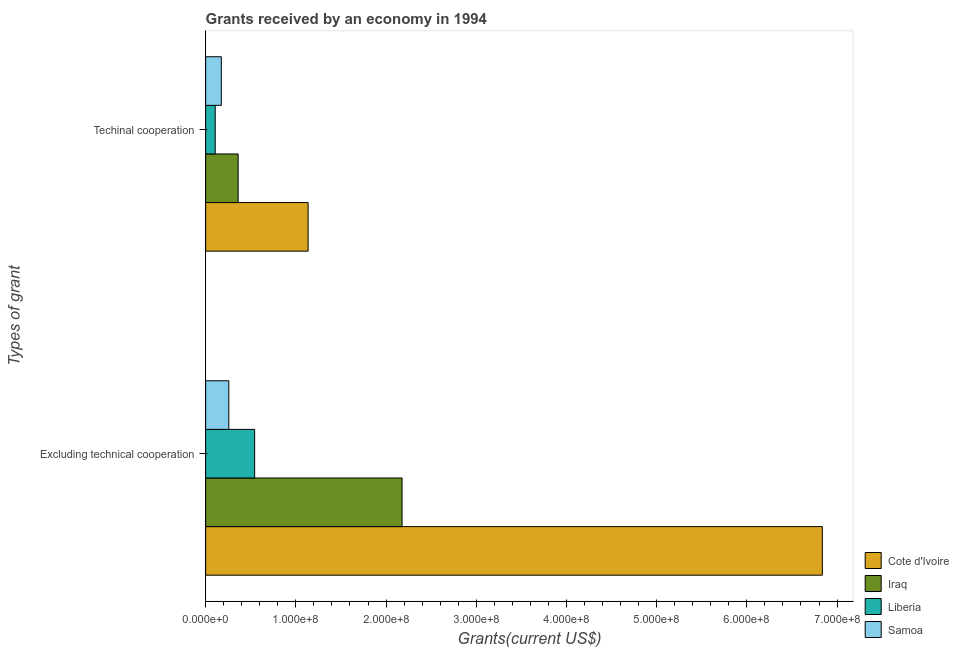How many different coloured bars are there?
Give a very brief answer. 4. Are the number of bars per tick equal to the number of legend labels?
Ensure brevity in your answer.  Yes. Are the number of bars on each tick of the Y-axis equal?
Provide a short and direct response. Yes. How many bars are there on the 1st tick from the top?
Ensure brevity in your answer.  4. What is the label of the 2nd group of bars from the top?
Ensure brevity in your answer.  Excluding technical cooperation. What is the amount of grants received(excluding technical cooperation) in Iraq?
Provide a short and direct response. 2.18e+08. Across all countries, what is the maximum amount of grants received(excluding technical cooperation)?
Make the answer very short. 6.84e+08. Across all countries, what is the minimum amount of grants received(including technical cooperation)?
Offer a very short reply. 1.06e+07. In which country was the amount of grants received(excluding technical cooperation) maximum?
Give a very brief answer. Cote d'Ivoire. In which country was the amount of grants received(excluding technical cooperation) minimum?
Your answer should be very brief. Samoa. What is the total amount of grants received(including technical cooperation) in the graph?
Make the answer very short. 1.78e+08. What is the difference between the amount of grants received(excluding technical cooperation) in Iraq and that in Cote d'Ivoire?
Provide a succinct answer. -4.66e+08. What is the difference between the amount of grants received(excluding technical cooperation) in Iraq and the amount of grants received(including technical cooperation) in Samoa?
Give a very brief answer. 2.00e+08. What is the average amount of grants received(excluding technical cooperation) per country?
Provide a short and direct response. 2.45e+08. What is the difference between the amount of grants received(including technical cooperation) and amount of grants received(excluding technical cooperation) in Iraq?
Your response must be concise. -1.82e+08. What is the ratio of the amount of grants received(excluding technical cooperation) in Cote d'Ivoire to that in Samoa?
Your answer should be very brief. 26.6. In how many countries, is the amount of grants received(including technical cooperation) greater than the average amount of grants received(including technical cooperation) taken over all countries?
Provide a succinct answer. 1. What does the 2nd bar from the top in Techinal cooperation represents?
Offer a very short reply. Liberia. What does the 4th bar from the bottom in Excluding technical cooperation represents?
Provide a succinct answer. Samoa. Are all the bars in the graph horizontal?
Ensure brevity in your answer.  Yes. How many countries are there in the graph?
Give a very brief answer. 4. Are the values on the major ticks of X-axis written in scientific E-notation?
Provide a short and direct response. Yes. Where does the legend appear in the graph?
Offer a terse response. Bottom right. How are the legend labels stacked?
Offer a terse response. Vertical. What is the title of the graph?
Give a very brief answer. Grants received by an economy in 1994. What is the label or title of the X-axis?
Your answer should be very brief. Grants(current US$). What is the label or title of the Y-axis?
Provide a short and direct response. Types of grant. What is the Grants(current US$) in Cote d'Ivoire in Excluding technical cooperation?
Provide a succinct answer. 6.84e+08. What is the Grants(current US$) in Iraq in Excluding technical cooperation?
Provide a succinct answer. 2.18e+08. What is the Grants(current US$) of Liberia in Excluding technical cooperation?
Offer a very short reply. 5.43e+07. What is the Grants(current US$) in Samoa in Excluding technical cooperation?
Offer a very short reply. 2.57e+07. What is the Grants(current US$) of Cote d'Ivoire in Techinal cooperation?
Offer a very short reply. 1.14e+08. What is the Grants(current US$) of Iraq in Techinal cooperation?
Your answer should be very brief. 3.61e+07. What is the Grants(current US$) in Liberia in Techinal cooperation?
Keep it short and to the point. 1.06e+07. What is the Grants(current US$) of Samoa in Techinal cooperation?
Keep it short and to the point. 1.74e+07. Across all Types of grant, what is the maximum Grants(current US$) in Cote d'Ivoire?
Your response must be concise. 6.84e+08. Across all Types of grant, what is the maximum Grants(current US$) of Iraq?
Your answer should be compact. 2.18e+08. Across all Types of grant, what is the maximum Grants(current US$) of Liberia?
Give a very brief answer. 5.43e+07. Across all Types of grant, what is the maximum Grants(current US$) of Samoa?
Keep it short and to the point. 2.57e+07. Across all Types of grant, what is the minimum Grants(current US$) of Cote d'Ivoire?
Your answer should be compact. 1.14e+08. Across all Types of grant, what is the minimum Grants(current US$) in Iraq?
Make the answer very short. 3.61e+07. Across all Types of grant, what is the minimum Grants(current US$) in Liberia?
Your response must be concise. 1.06e+07. Across all Types of grant, what is the minimum Grants(current US$) in Samoa?
Make the answer very short. 1.74e+07. What is the total Grants(current US$) of Cote d'Ivoire in the graph?
Your answer should be very brief. 7.97e+08. What is the total Grants(current US$) of Iraq in the graph?
Your answer should be very brief. 2.54e+08. What is the total Grants(current US$) of Liberia in the graph?
Offer a terse response. 6.50e+07. What is the total Grants(current US$) of Samoa in the graph?
Ensure brevity in your answer.  4.31e+07. What is the difference between the Grants(current US$) in Cote d'Ivoire in Excluding technical cooperation and that in Techinal cooperation?
Ensure brevity in your answer.  5.70e+08. What is the difference between the Grants(current US$) in Iraq in Excluding technical cooperation and that in Techinal cooperation?
Ensure brevity in your answer.  1.82e+08. What is the difference between the Grants(current US$) in Liberia in Excluding technical cooperation and that in Techinal cooperation?
Keep it short and to the point. 4.37e+07. What is the difference between the Grants(current US$) of Samoa in Excluding technical cooperation and that in Techinal cooperation?
Provide a short and direct response. 8.31e+06. What is the difference between the Grants(current US$) in Cote d'Ivoire in Excluding technical cooperation and the Grants(current US$) in Iraq in Techinal cooperation?
Your response must be concise. 6.48e+08. What is the difference between the Grants(current US$) in Cote d'Ivoire in Excluding technical cooperation and the Grants(current US$) in Liberia in Techinal cooperation?
Keep it short and to the point. 6.73e+08. What is the difference between the Grants(current US$) in Cote d'Ivoire in Excluding technical cooperation and the Grants(current US$) in Samoa in Techinal cooperation?
Your answer should be very brief. 6.66e+08. What is the difference between the Grants(current US$) in Iraq in Excluding technical cooperation and the Grants(current US$) in Liberia in Techinal cooperation?
Keep it short and to the point. 2.07e+08. What is the difference between the Grants(current US$) of Iraq in Excluding technical cooperation and the Grants(current US$) of Samoa in Techinal cooperation?
Provide a succinct answer. 2.00e+08. What is the difference between the Grants(current US$) of Liberia in Excluding technical cooperation and the Grants(current US$) of Samoa in Techinal cooperation?
Offer a very short reply. 3.70e+07. What is the average Grants(current US$) in Cote d'Ivoire per Types of grant?
Your answer should be compact. 3.99e+08. What is the average Grants(current US$) in Iraq per Types of grant?
Your answer should be compact. 1.27e+08. What is the average Grants(current US$) in Liberia per Types of grant?
Make the answer very short. 3.25e+07. What is the average Grants(current US$) of Samoa per Types of grant?
Your response must be concise. 2.15e+07. What is the difference between the Grants(current US$) in Cote d'Ivoire and Grants(current US$) in Iraq in Excluding technical cooperation?
Make the answer very short. 4.66e+08. What is the difference between the Grants(current US$) in Cote d'Ivoire and Grants(current US$) in Liberia in Excluding technical cooperation?
Your answer should be very brief. 6.29e+08. What is the difference between the Grants(current US$) of Cote d'Ivoire and Grants(current US$) of Samoa in Excluding technical cooperation?
Offer a very short reply. 6.58e+08. What is the difference between the Grants(current US$) in Iraq and Grants(current US$) in Liberia in Excluding technical cooperation?
Provide a succinct answer. 1.63e+08. What is the difference between the Grants(current US$) in Iraq and Grants(current US$) in Samoa in Excluding technical cooperation?
Your answer should be compact. 1.92e+08. What is the difference between the Grants(current US$) in Liberia and Grants(current US$) in Samoa in Excluding technical cooperation?
Ensure brevity in your answer.  2.86e+07. What is the difference between the Grants(current US$) of Cote d'Ivoire and Grants(current US$) of Iraq in Techinal cooperation?
Offer a terse response. 7.76e+07. What is the difference between the Grants(current US$) of Cote d'Ivoire and Grants(current US$) of Liberia in Techinal cooperation?
Offer a very short reply. 1.03e+08. What is the difference between the Grants(current US$) in Cote d'Ivoire and Grants(current US$) in Samoa in Techinal cooperation?
Ensure brevity in your answer.  9.62e+07. What is the difference between the Grants(current US$) of Iraq and Grants(current US$) of Liberia in Techinal cooperation?
Your response must be concise. 2.54e+07. What is the difference between the Grants(current US$) in Iraq and Grants(current US$) in Samoa in Techinal cooperation?
Your response must be concise. 1.87e+07. What is the difference between the Grants(current US$) of Liberia and Grants(current US$) of Samoa in Techinal cooperation?
Provide a succinct answer. -6.77e+06. What is the ratio of the Grants(current US$) of Cote d'Ivoire in Excluding technical cooperation to that in Techinal cooperation?
Make the answer very short. 6.02. What is the ratio of the Grants(current US$) in Iraq in Excluding technical cooperation to that in Techinal cooperation?
Keep it short and to the point. 6.04. What is the ratio of the Grants(current US$) in Liberia in Excluding technical cooperation to that in Techinal cooperation?
Offer a terse response. 5.12. What is the ratio of the Grants(current US$) of Samoa in Excluding technical cooperation to that in Techinal cooperation?
Offer a terse response. 1.48. What is the difference between the highest and the second highest Grants(current US$) in Cote d'Ivoire?
Give a very brief answer. 5.70e+08. What is the difference between the highest and the second highest Grants(current US$) in Iraq?
Offer a very short reply. 1.82e+08. What is the difference between the highest and the second highest Grants(current US$) of Liberia?
Your answer should be compact. 4.37e+07. What is the difference between the highest and the second highest Grants(current US$) in Samoa?
Keep it short and to the point. 8.31e+06. What is the difference between the highest and the lowest Grants(current US$) in Cote d'Ivoire?
Ensure brevity in your answer.  5.70e+08. What is the difference between the highest and the lowest Grants(current US$) in Iraq?
Your response must be concise. 1.82e+08. What is the difference between the highest and the lowest Grants(current US$) in Liberia?
Ensure brevity in your answer.  4.37e+07. What is the difference between the highest and the lowest Grants(current US$) in Samoa?
Ensure brevity in your answer.  8.31e+06. 